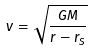Convert formula to latex. <formula><loc_0><loc_0><loc_500><loc_500>v = { \sqrt { \frac { G M } { r - r _ { S } } } }</formula> 